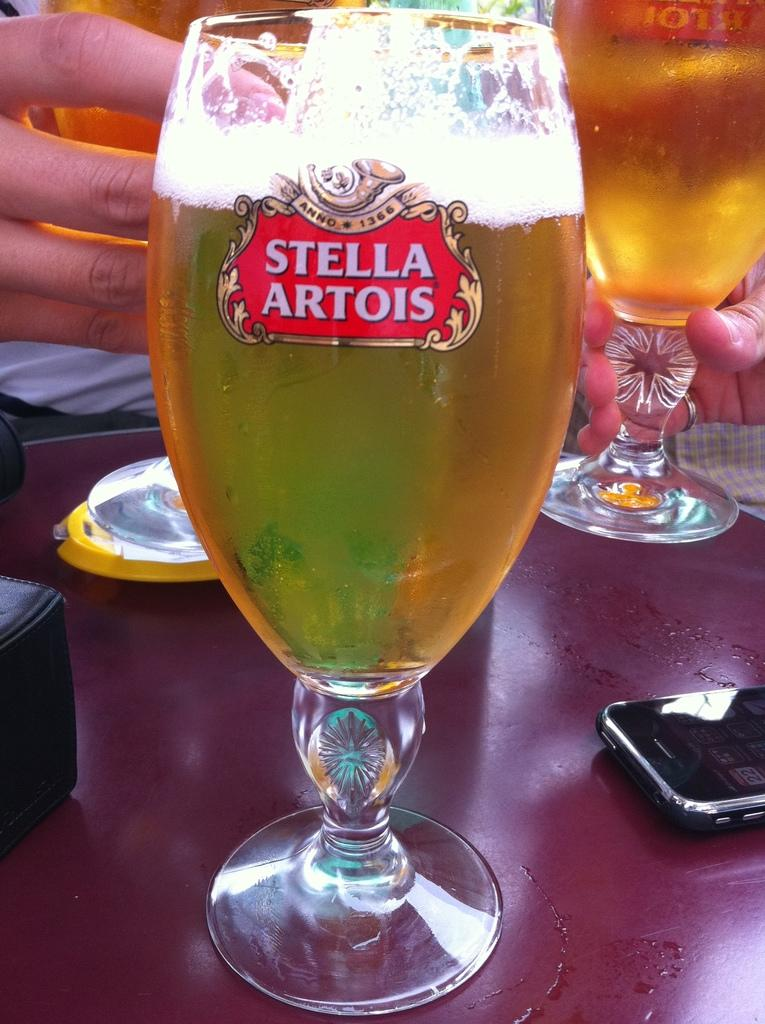<image>
Create a compact narrative representing the image presented. Beer is filled in a tall glass that reads "Stella Artois" 